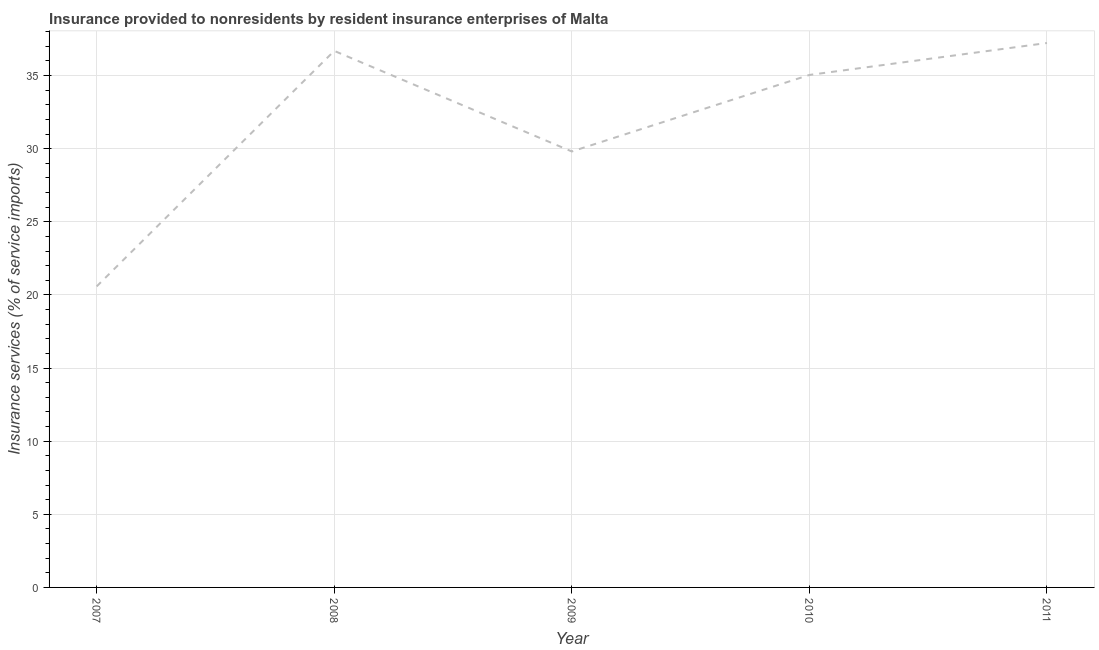What is the insurance and financial services in 2007?
Your answer should be compact. 20.58. Across all years, what is the maximum insurance and financial services?
Ensure brevity in your answer.  37.23. Across all years, what is the minimum insurance and financial services?
Ensure brevity in your answer.  20.58. In which year was the insurance and financial services minimum?
Keep it short and to the point. 2007. What is the sum of the insurance and financial services?
Provide a short and direct response. 159.34. What is the difference between the insurance and financial services in 2007 and 2009?
Your answer should be very brief. -9.23. What is the average insurance and financial services per year?
Your answer should be very brief. 31.87. What is the median insurance and financial services?
Your answer should be very brief. 35.04. What is the ratio of the insurance and financial services in 2009 to that in 2010?
Offer a very short reply. 0.85. What is the difference between the highest and the second highest insurance and financial services?
Offer a terse response. 0.54. What is the difference between the highest and the lowest insurance and financial services?
Provide a short and direct response. 16.64. In how many years, is the insurance and financial services greater than the average insurance and financial services taken over all years?
Offer a very short reply. 3. How many lines are there?
Offer a terse response. 1. Are the values on the major ticks of Y-axis written in scientific E-notation?
Make the answer very short. No. Does the graph contain grids?
Ensure brevity in your answer.  Yes. What is the title of the graph?
Provide a short and direct response. Insurance provided to nonresidents by resident insurance enterprises of Malta. What is the label or title of the X-axis?
Provide a short and direct response. Year. What is the label or title of the Y-axis?
Your response must be concise. Insurance services (% of service imports). What is the Insurance services (% of service imports) of 2007?
Offer a terse response. 20.58. What is the Insurance services (% of service imports) of 2008?
Ensure brevity in your answer.  36.69. What is the Insurance services (% of service imports) in 2009?
Offer a very short reply. 29.81. What is the Insurance services (% of service imports) of 2010?
Offer a terse response. 35.04. What is the Insurance services (% of service imports) in 2011?
Keep it short and to the point. 37.23. What is the difference between the Insurance services (% of service imports) in 2007 and 2008?
Give a very brief answer. -16.1. What is the difference between the Insurance services (% of service imports) in 2007 and 2009?
Offer a terse response. -9.23. What is the difference between the Insurance services (% of service imports) in 2007 and 2010?
Offer a very short reply. -14.46. What is the difference between the Insurance services (% of service imports) in 2007 and 2011?
Offer a terse response. -16.64. What is the difference between the Insurance services (% of service imports) in 2008 and 2009?
Provide a succinct answer. 6.88. What is the difference between the Insurance services (% of service imports) in 2008 and 2010?
Ensure brevity in your answer.  1.64. What is the difference between the Insurance services (% of service imports) in 2008 and 2011?
Keep it short and to the point. -0.54. What is the difference between the Insurance services (% of service imports) in 2009 and 2010?
Your answer should be compact. -5.23. What is the difference between the Insurance services (% of service imports) in 2009 and 2011?
Your response must be concise. -7.42. What is the difference between the Insurance services (% of service imports) in 2010 and 2011?
Offer a terse response. -2.18. What is the ratio of the Insurance services (% of service imports) in 2007 to that in 2008?
Keep it short and to the point. 0.56. What is the ratio of the Insurance services (% of service imports) in 2007 to that in 2009?
Give a very brief answer. 0.69. What is the ratio of the Insurance services (% of service imports) in 2007 to that in 2010?
Keep it short and to the point. 0.59. What is the ratio of the Insurance services (% of service imports) in 2007 to that in 2011?
Make the answer very short. 0.55. What is the ratio of the Insurance services (% of service imports) in 2008 to that in 2009?
Give a very brief answer. 1.23. What is the ratio of the Insurance services (% of service imports) in 2008 to that in 2010?
Your answer should be compact. 1.05. What is the ratio of the Insurance services (% of service imports) in 2008 to that in 2011?
Make the answer very short. 0.99. What is the ratio of the Insurance services (% of service imports) in 2009 to that in 2010?
Ensure brevity in your answer.  0.85. What is the ratio of the Insurance services (% of service imports) in 2009 to that in 2011?
Ensure brevity in your answer.  0.8. What is the ratio of the Insurance services (% of service imports) in 2010 to that in 2011?
Offer a very short reply. 0.94. 